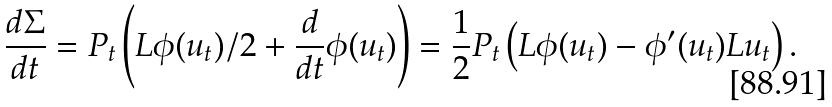Convert formula to latex. <formula><loc_0><loc_0><loc_500><loc_500>\frac { d \Sigma } { d t } = P _ { t } \left ( L \phi ( u _ { t } ) / 2 + \frac { d } { d t } \phi ( u _ { t } ) \right ) = \frac { 1 } { 2 } P _ { t } \left ( L \phi ( u _ { t } ) - \phi ^ { \prime } ( u _ { t } ) L u _ { t } \right ) .</formula> 